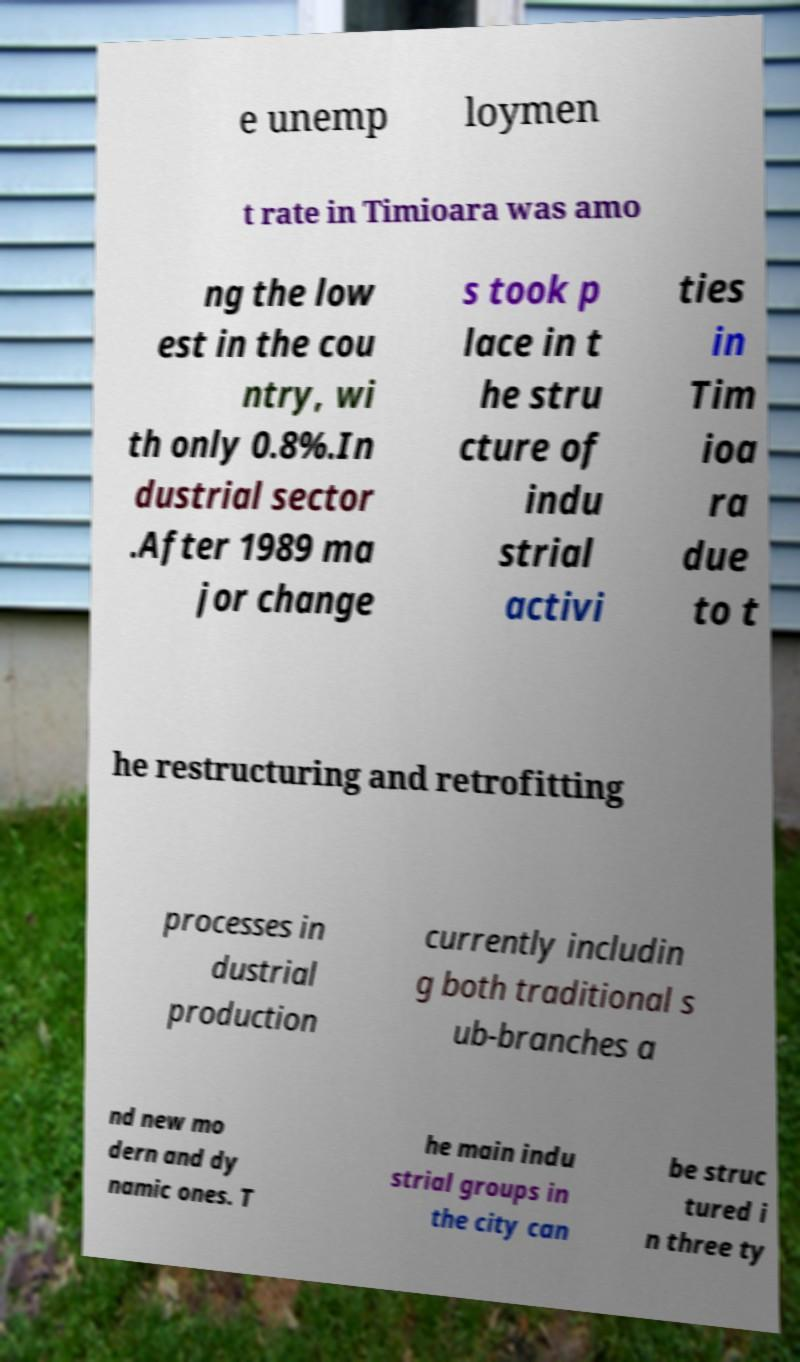Can you accurately transcribe the text from the provided image for me? e unemp loymen t rate in Timioara was amo ng the low est in the cou ntry, wi th only 0.8%.In dustrial sector .After 1989 ma jor change s took p lace in t he stru cture of indu strial activi ties in Tim ioa ra due to t he restructuring and retrofitting processes in dustrial production currently includin g both traditional s ub-branches a nd new mo dern and dy namic ones. T he main indu strial groups in the city can be struc tured i n three ty 